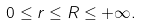Convert formula to latex. <formula><loc_0><loc_0><loc_500><loc_500>0 \leq r \leq R \leq + \infty .</formula> 